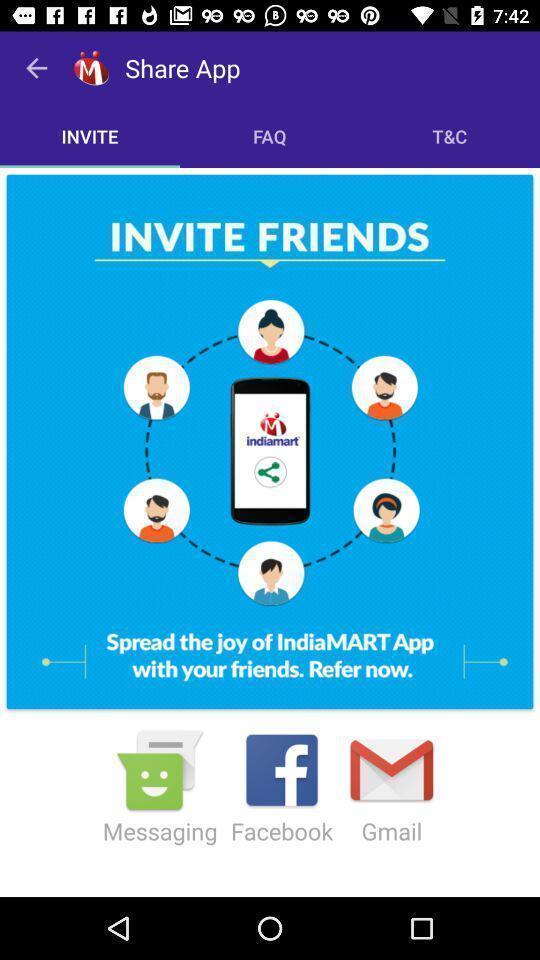What can you discern from this picture? Page to invite friends through social applications. 